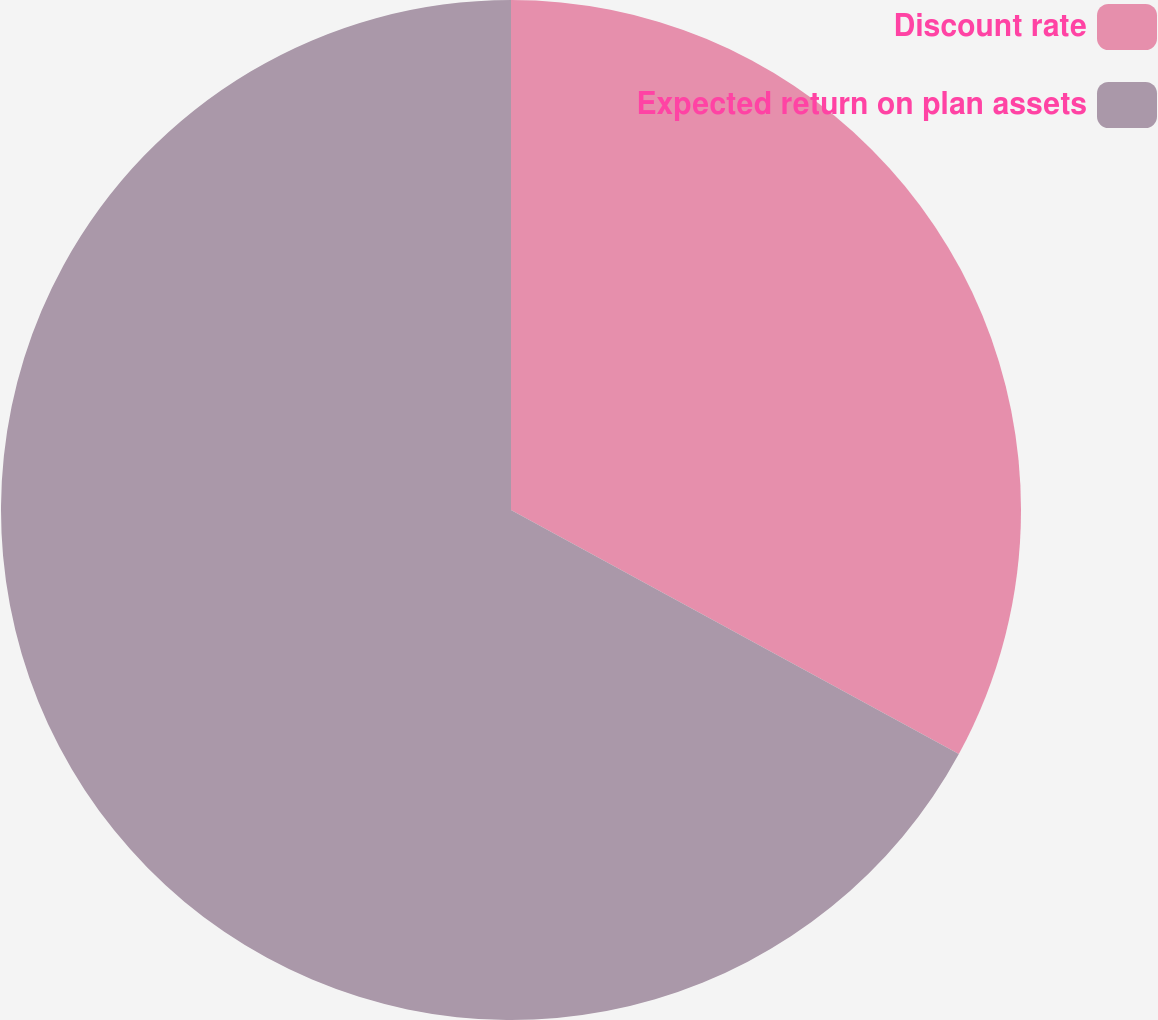Convert chart to OTSL. <chart><loc_0><loc_0><loc_500><loc_500><pie_chart><fcel>Discount rate<fcel>Expected return on plan assets<nl><fcel>32.94%<fcel>67.06%<nl></chart> 